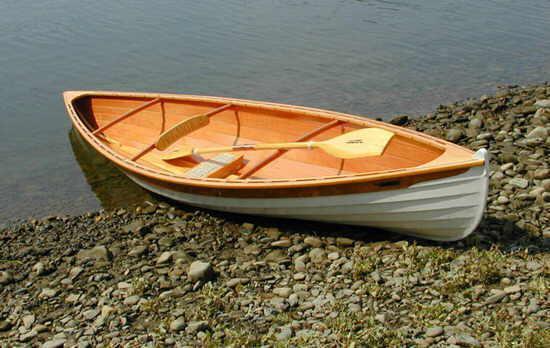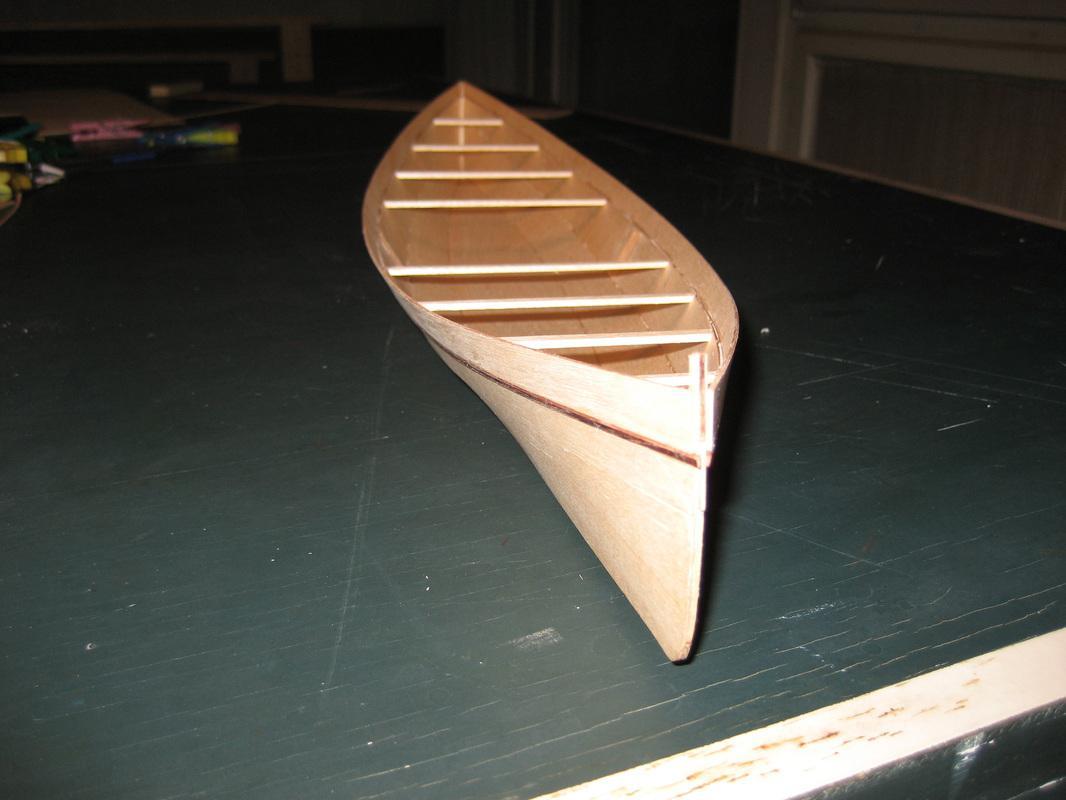The first image is the image on the left, the second image is the image on the right. Examine the images to the left and right. Is the description "One image shows at least three empty red canoes parked close together on water, and the other image includes at least one oar." accurate? Answer yes or no. No. 